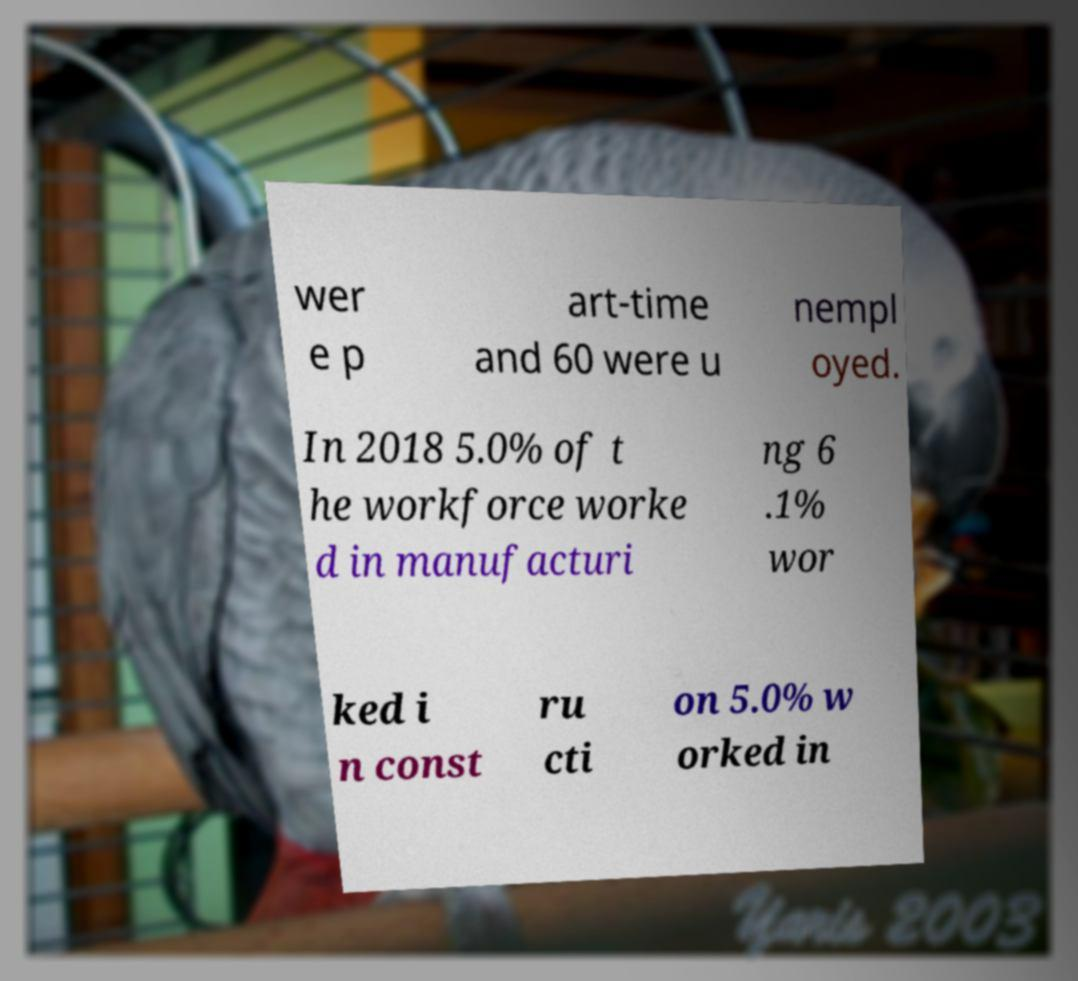Please read and relay the text visible in this image. What does it say? wer e p art-time and 60 were u nempl oyed. In 2018 5.0% of t he workforce worke d in manufacturi ng 6 .1% wor ked i n const ru cti on 5.0% w orked in 